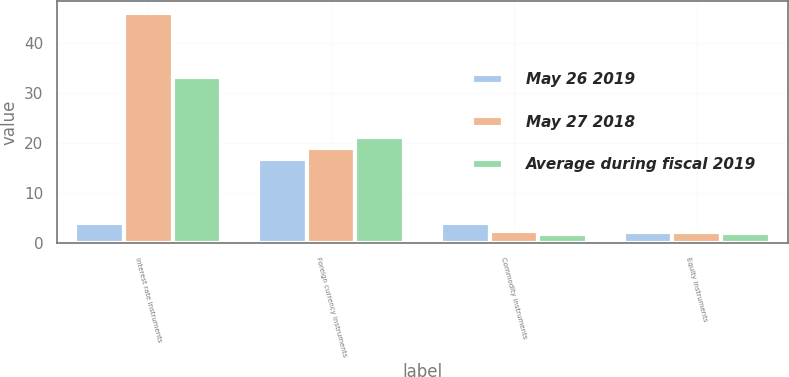Convert chart to OTSL. <chart><loc_0><loc_0><loc_500><loc_500><stacked_bar_chart><ecel><fcel>Interest rate instruments<fcel>Foreign currency instruments<fcel>Commodity instruments<fcel>Equity instruments<nl><fcel>May 26 2019<fcel>4.1<fcel>16.8<fcel>4.1<fcel>2.3<nl><fcel>May 27 2018<fcel>46.1<fcel>19<fcel>2.5<fcel>2.2<nl><fcel>Average during fiscal 2019<fcel>33.2<fcel>21.3<fcel>1.9<fcel>2<nl></chart> 